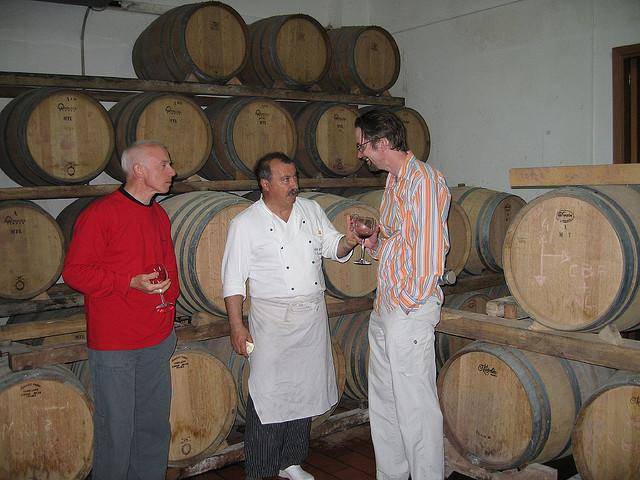What is contained inside the brown barrels? wine 